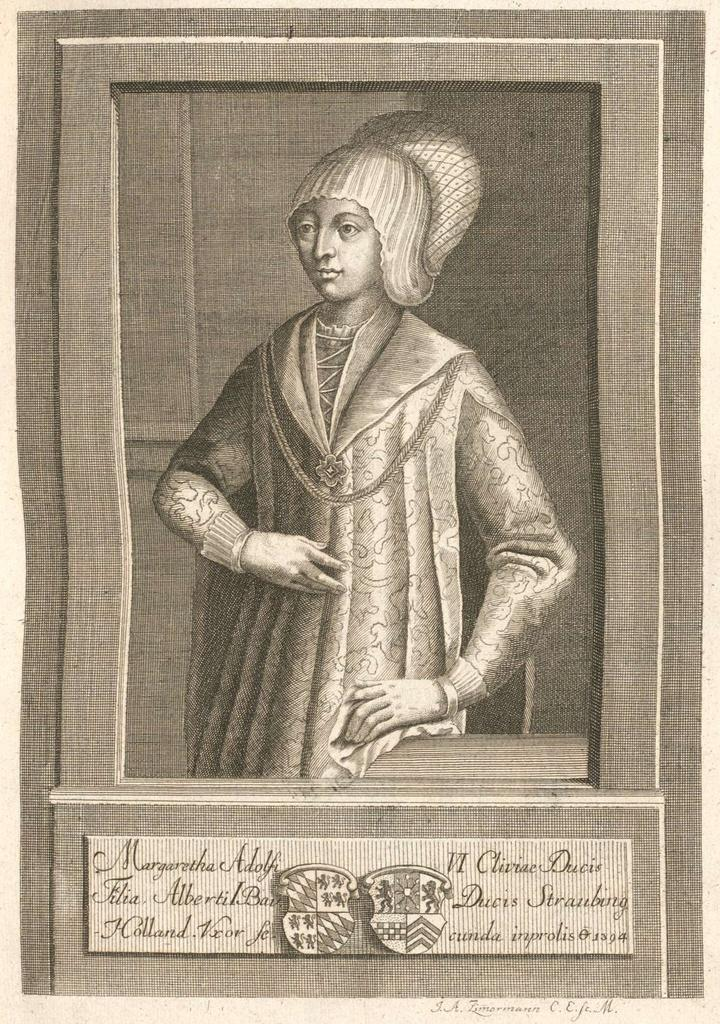What is the main subject of the image? There is a picture of a person in the image. Is there any text associated with the image? Yes, there is text at the bottom of the image. Can you describe the garden in the image? There is no garden present in the image; it features a picture of a person and text at the bottom. What type of bat is flying in the image? There is no bat present in the image. 